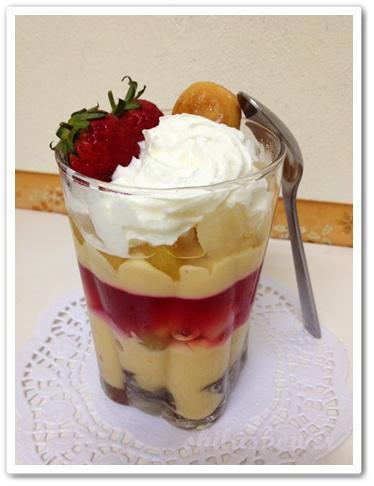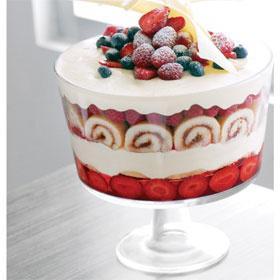The first image is the image on the left, the second image is the image on the right. For the images displayed, is the sentence "The left image shows one dessert with one spoon." factually correct? Answer yes or no. Yes. 